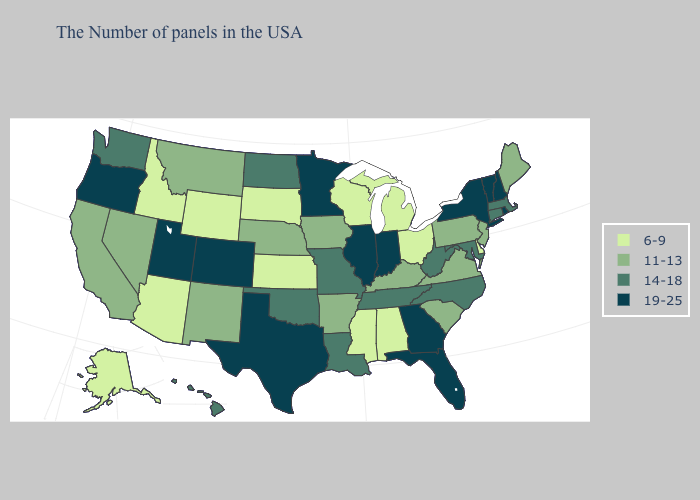Does New York have the highest value in the Northeast?
Concise answer only. Yes. What is the value of Montana?
Be succinct. 11-13. Name the states that have a value in the range 19-25?
Quick response, please. Rhode Island, New Hampshire, Vermont, New York, Florida, Georgia, Indiana, Illinois, Minnesota, Texas, Colorado, Utah, Oregon. What is the value of Oklahoma?
Answer briefly. 14-18. Name the states that have a value in the range 14-18?
Give a very brief answer. Massachusetts, Connecticut, Maryland, North Carolina, West Virginia, Tennessee, Louisiana, Missouri, Oklahoma, North Dakota, Washington, Hawaii. Name the states that have a value in the range 11-13?
Quick response, please. Maine, New Jersey, Pennsylvania, Virginia, South Carolina, Kentucky, Arkansas, Iowa, Nebraska, New Mexico, Montana, Nevada, California. Name the states that have a value in the range 6-9?
Write a very short answer. Delaware, Ohio, Michigan, Alabama, Wisconsin, Mississippi, Kansas, South Dakota, Wyoming, Arizona, Idaho, Alaska. Name the states that have a value in the range 11-13?
Answer briefly. Maine, New Jersey, Pennsylvania, Virginia, South Carolina, Kentucky, Arkansas, Iowa, Nebraska, New Mexico, Montana, Nevada, California. Which states have the highest value in the USA?
Concise answer only. Rhode Island, New Hampshire, Vermont, New York, Florida, Georgia, Indiana, Illinois, Minnesota, Texas, Colorado, Utah, Oregon. What is the value of Tennessee?
Quick response, please. 14-18. Does Florida have the highest value in the USA?
Short answer required. Yes. What is the highest value in the USA?
Be succinct. 19-25. Is the legend a continuous bar?
Keep it brief. No. What is the value of South Carolina?
Quick response, please. 11-13. Does Maryland have a lower value than Florida?
Quick response, please. Yes. 